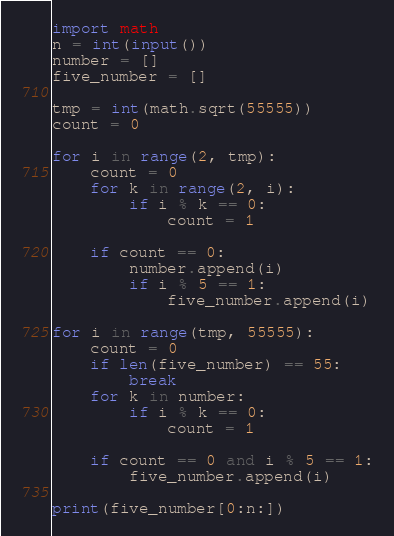Convert code to text. <code><loc_0><loc_0><loc_500><loc_500><_Python_>import math
n = int(input())
number = []
five_number = []

tmp = int(math.sqrt(55555))
count = 0

for i in range(2, tmp):
    count = 0
    for k in range(2, i):
        if i % k == 0:
            count = 1

    if count == 0:
        number.append(i)
        if i % 5 == 1:
            five_number.append(i)

for i in range(tmp, 55555):
    count = 0
    if len(five_number) == 55:
        break
    for k in number:
        if i % k == 0:
            count = 1

    if count == 0 and i % 5 == 1:
        five_number.append(i)

print(five_number[0:n:])
</code> 